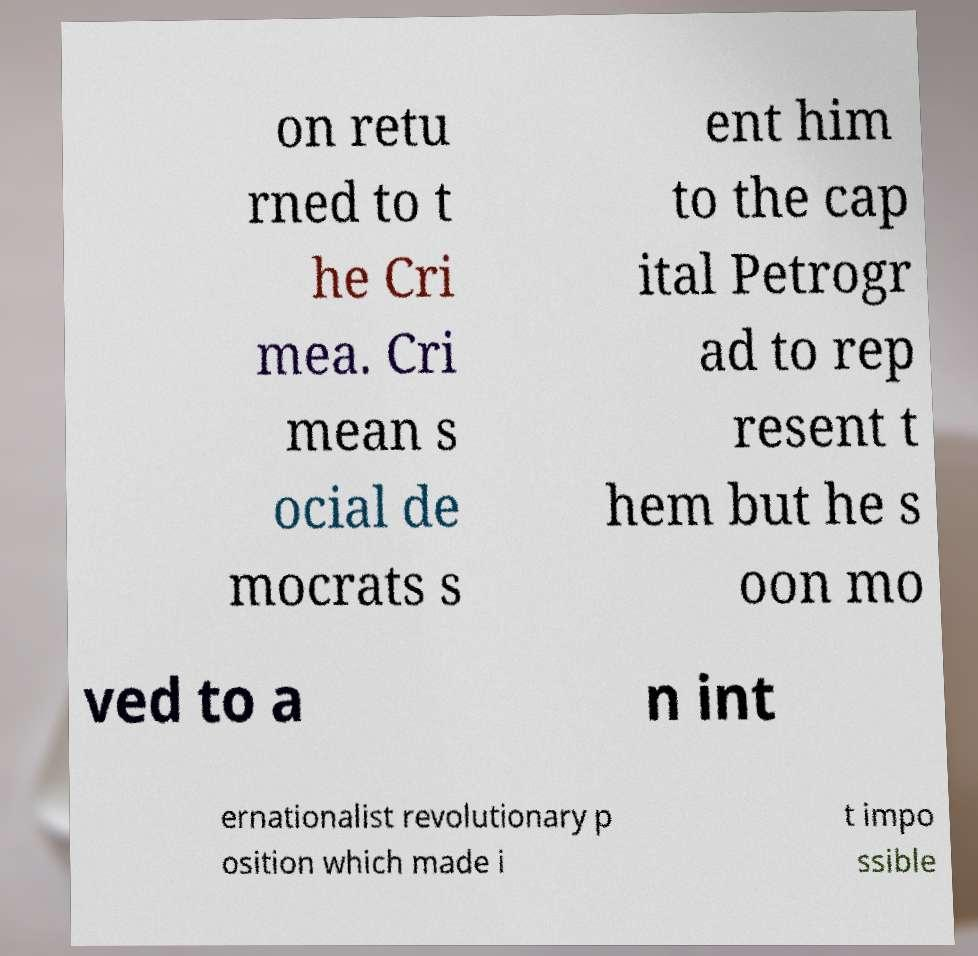Could you assist in decoding the text presented in this image and type it out clearly? on retu rned to t he Cri mea. Cri mean s ocial de mocrats s ent him to the cap ital Petrogr ad to rep resent t hem but he s oon mo ved to a n int ernationalist revolutionary p osition which made i t impo ssible 